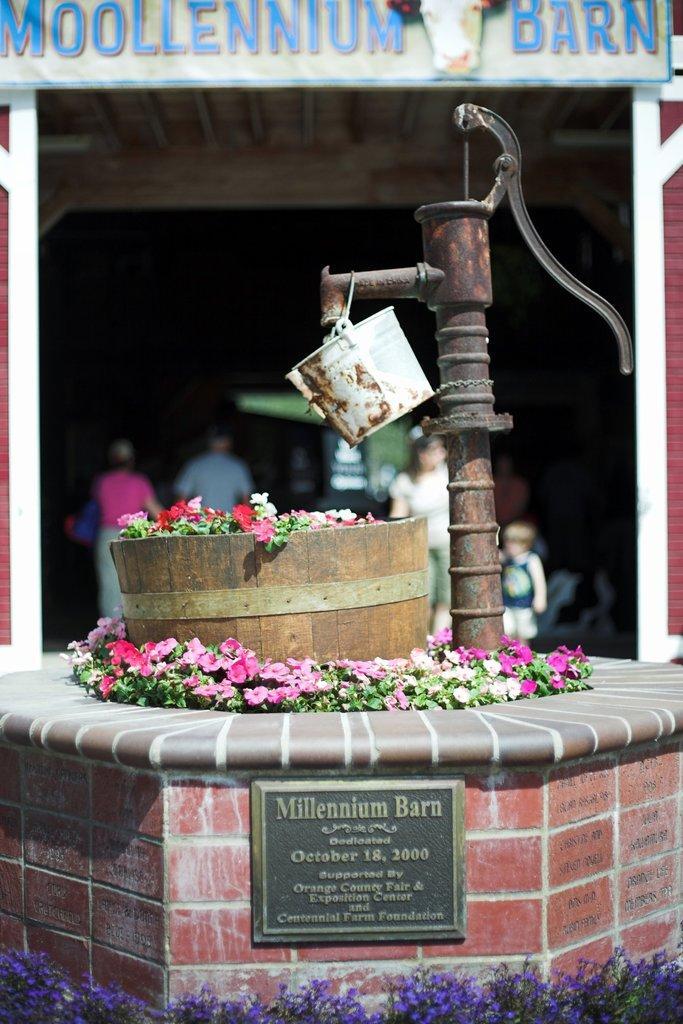How would you summarize this image in a sentence or two? In the picture I can see the hand bore pump on the right side and I can see a bucket. I can see the flowers in the wooden basket. I can see the memorial stone and flowering plants at the bottom of the picture. In the background, I can see a few persons. I can see the name plate board at the top of the picture. 